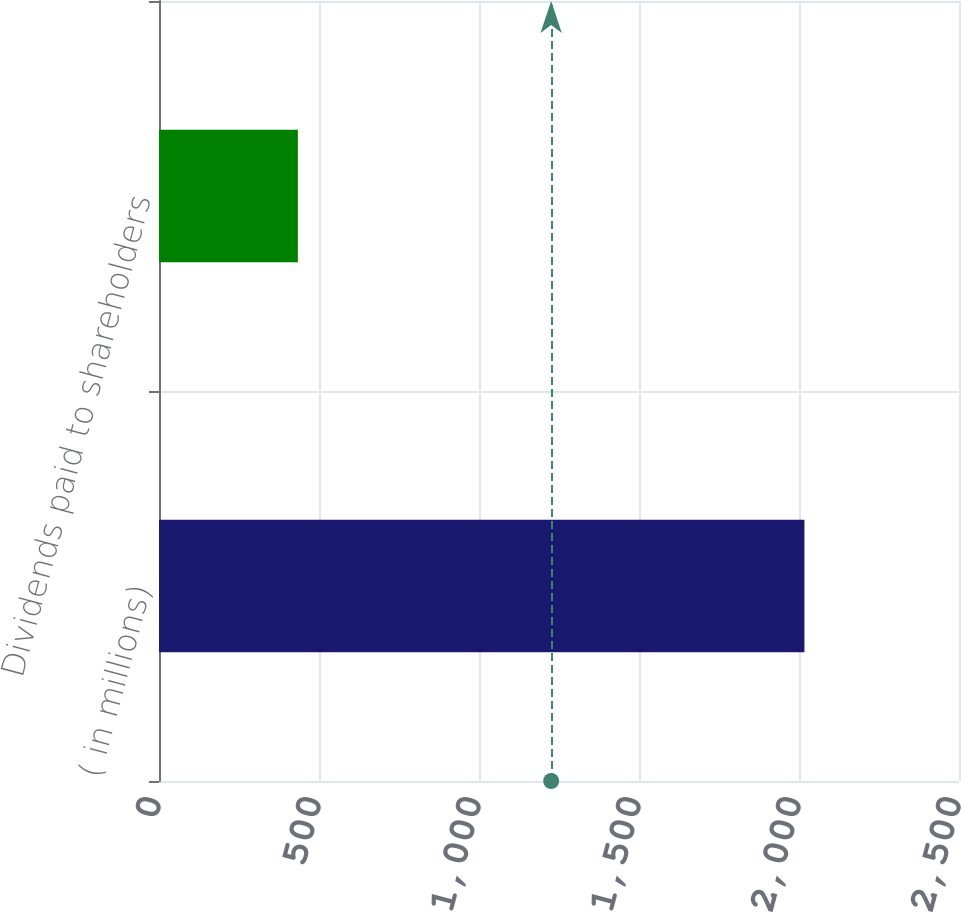Convert chart. <chart><loc_0><loc_0><loc_500><loc_500><bar_chart><fcel>( in millions)<fcel>Dividends paid to shareholders<nl><fcel>2017<fcel>434<nl></chart> 